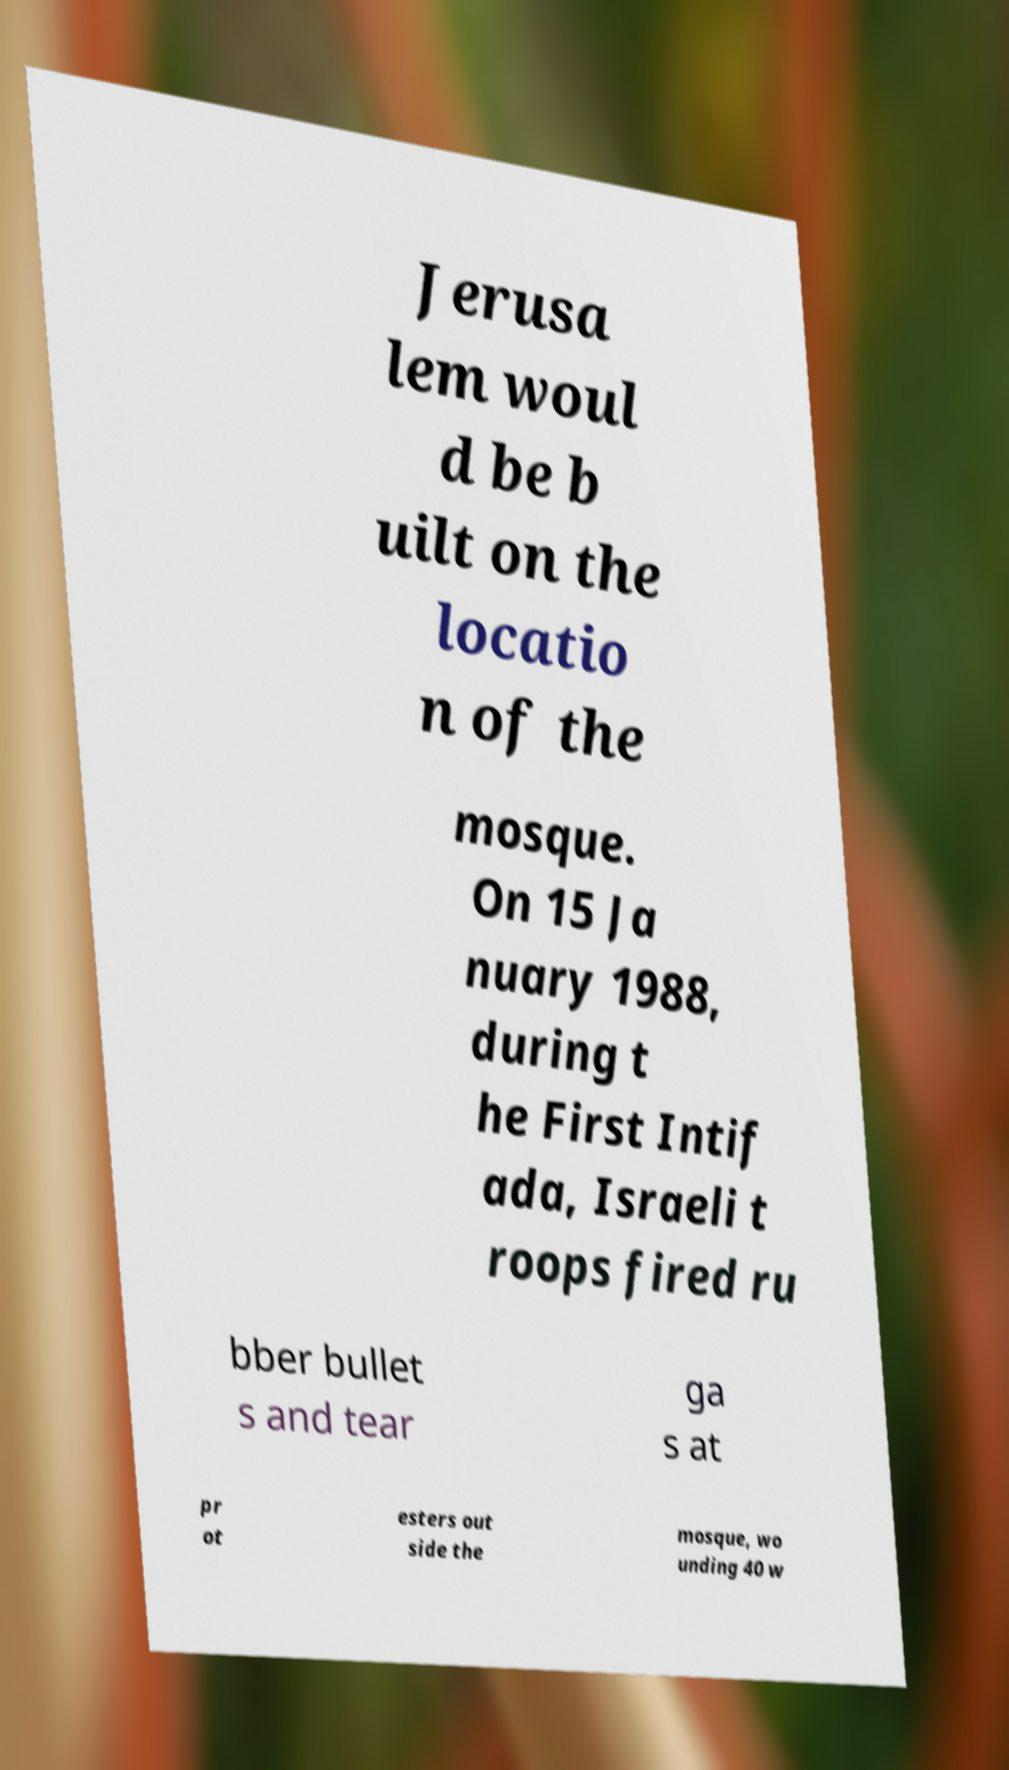I need the written content from this picture converted into text. Can you do that? Jerusa lem woul d be b uilt on the locatio n of the mosque. On 15 Ja nuary 1988, during t he First Intif ada, Israeli t roops fired ru bber bullet s and tear ga s at pr ot esters out side the mosque, wo unding 40 w 